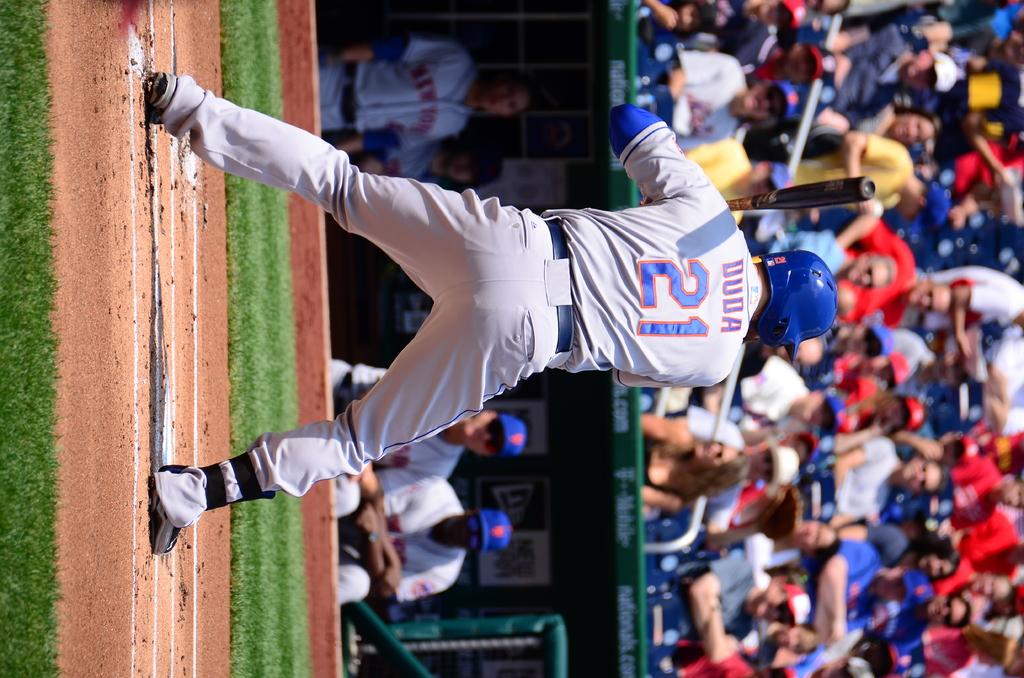<image>
Provide a brief description of the given image. a baseball player playing on the field jersey reads duda 